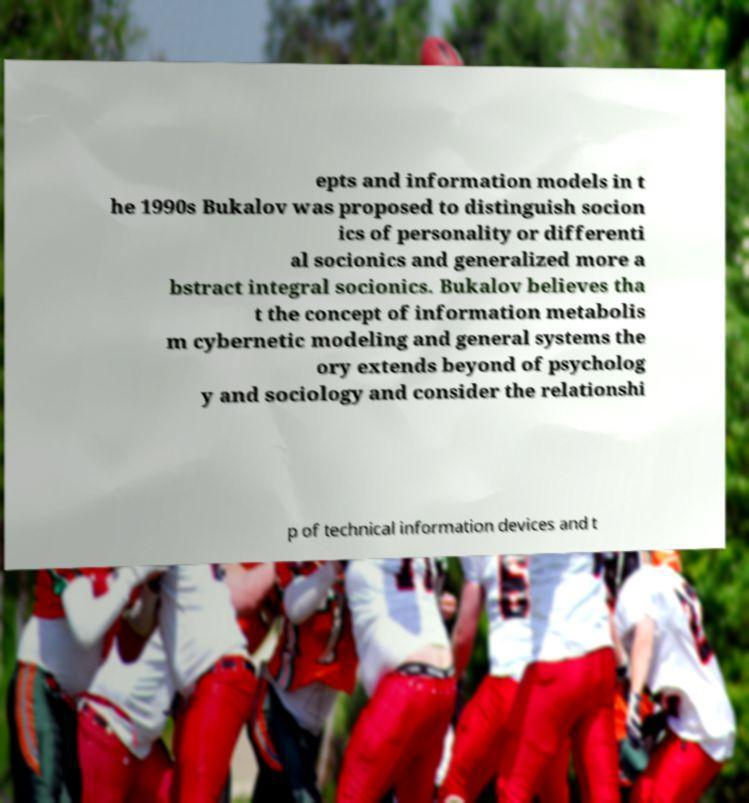Can you read and provide the text displayed in the image?This photo seems to have some interesting text. Can you extract and type it out for me? epts and information models in t he 1990s Bukalov was proposed to distinguish socion ics of personality or differenti al socionics and generalized more a bstract integral socionics. Bukalov believes tha t the concept of information metabolis m cybernetic modeling and general systems the ory extends beyond of psycholog y and sociology and consider the relationshi p of technical information devices and t 